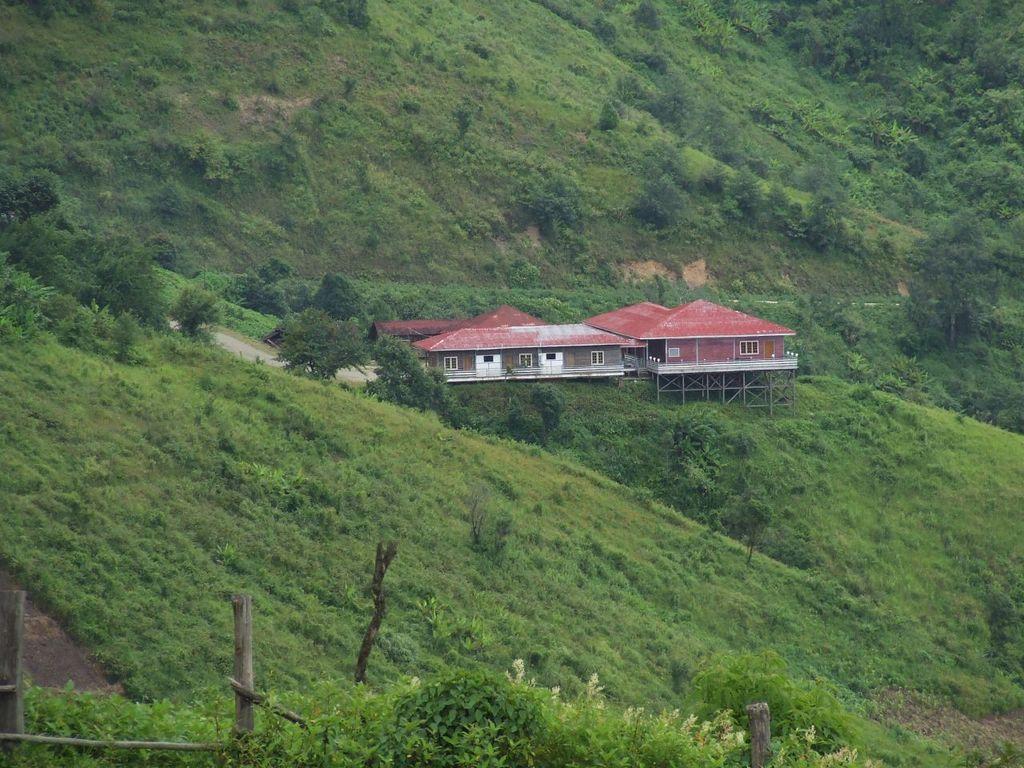Could you give a brief overview of what you see in this image? This image consists of a house. It looks like it is constructed on a mountain. At the bottom, there is green grass on the ground. In the background, there are mountains covered with plants and grass. On the left, we can see a fencing made up of wood. 